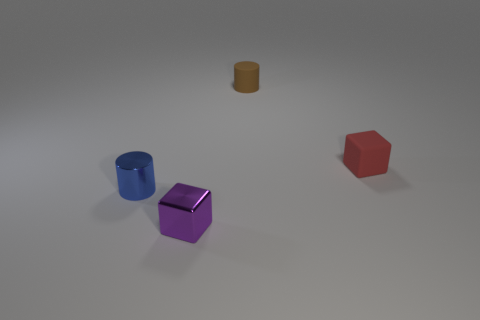Add 4 small purple metal blocks. How many objects exist? 8 Subtract all cyan shiny balls. Subtract all tiny metallic cylinders. How many objects are left? 3 Add 2 small purple shiny blocks. How many small purple shiny blocks are left? 3 Add 4 large yellow metal blocks. How many large yellow metal blocks exist? 4 Subtract 0 green spheres. How many objects are left? 4 